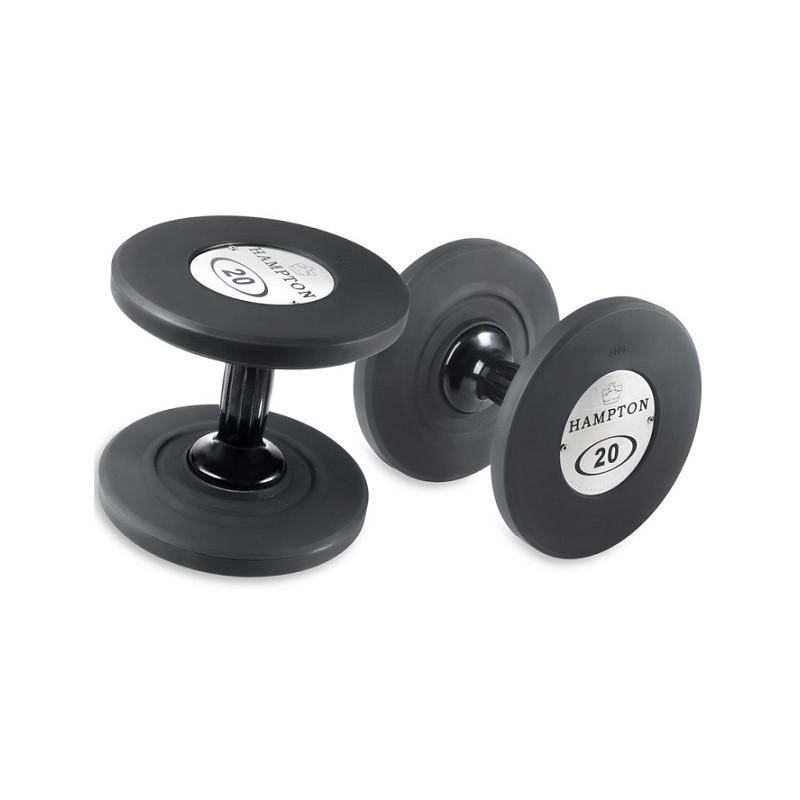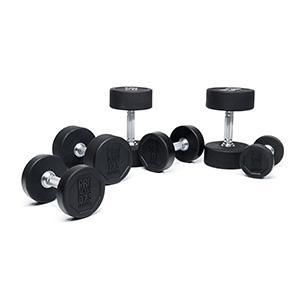The first image is the image on the left, the second image is the image on the right. Assess this claim about the two images: "The left image shows at least three black barbells.". Correct or not? Answer yes or no. No. The first image is the image on the left, the second image is the image on the right. Given the left and right images, does the statement "There are more dumbbells in the right image than in the left image." hold true? Answer yes or no. Yes. 